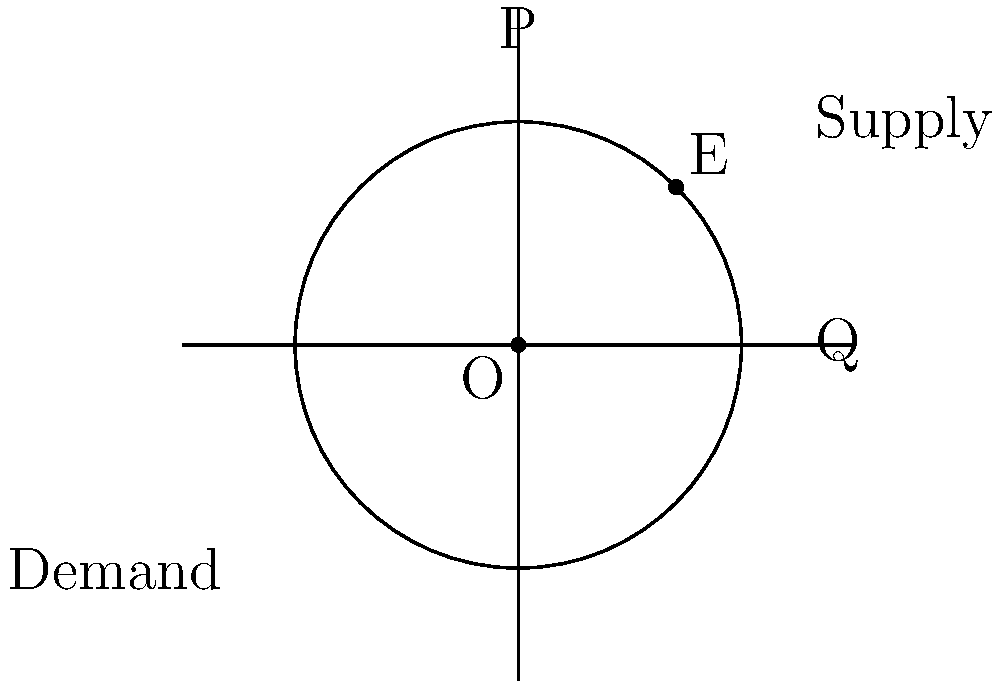In the circular economic model shown, where supply and demand curves are represented by tangent lines to the circle, point E represents the equilibrium point. If the radius of the circle is 2 units, what are the coordinates of the equilibrium point E? To solve this problem, we'll follow these steps:

1) The circle is centered at the origin (0,0) with a radius of 2 units.

2) The equilibrium point E is where the supply and demand curves (tangent lines) intersect.

3) Due to the symmetry of the circle and the positioning of the supply and demand curves, we know that E is on the line y = x in the first quadrant.

4) The equation of the circle is $x^2 + y^2 = 4$ (radius squared).

5) Since E is on both the circle and the line y = x, its coordinates (x,y) must satisfy both equations:
   
   $x^2 + y^2 = 4$ and $y = x$

6) Substituting y with x in the circle equation:
   
   $x^2 + x^2 = 4$
   $2x^2 = 4$
   $x^2 = 2$

7) Taking the square root of both sides:
   
   $x = \sqrt{2} \approx 1.414$

8) Since y = x, the y-coordinate is also $\sqrt{2}$

Therefore, the coordinates of E are $(\sqrt{2}, \sqrt{2})$ or approximately (1.414, 1.414).
Answer: $(\sqrt{2}, \sqrt{2})$ 